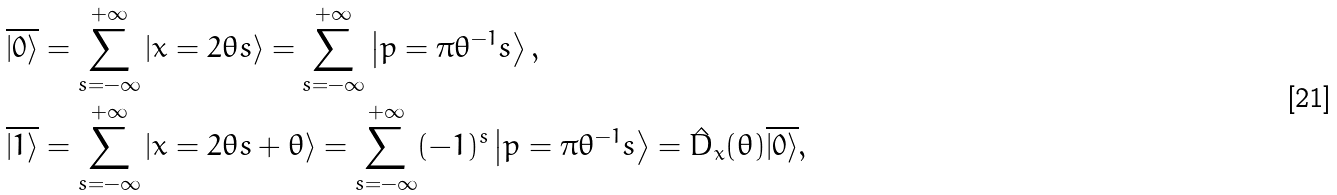<formula> <loc_0><loc_0><loc_500><loc_500>\overline { \left | 0 \right \rangle } & = \sum _ { s = - \infty } ^ { + \infty } \left | x = 2 \theta s \right \rangle = \sum _ { s = - \infty } ^ { + \infty } \left | p = \pi \theta ^ { - 1 } s \right \rangle , \\ \overline { \left | 1 \right \rangle } & = \sum _ { s = - \infty } ^ { + \infty } \left | x = 2 \theta s + \theta \right \rangle = \sum _ { s = - \infty } ^ { + \infty } ( - 1 ) ^ { s } \left | p = \pi \theta ^ { - 1 } s \right \rangle = \hat { D } _ { x } ( \theta ) \overline { \left | 0 \right \rangle } ,</formula> 